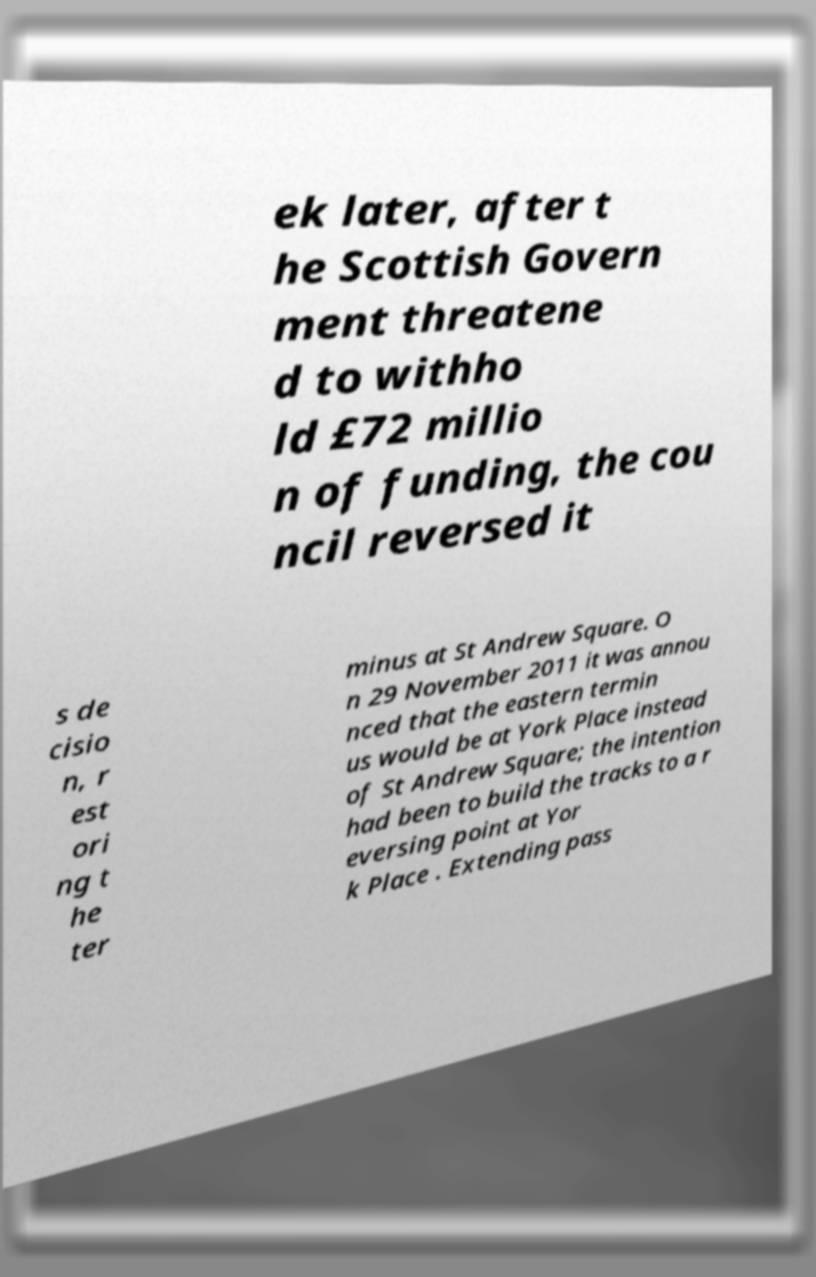For documentation purposes, I need the text within this image transcribed. Could you provide that? ek later, after t he Scottish Govern ment threatene d to withho ld £72 millio n of funding, the cou ncil reversed it s de cisio n, r est ori ng t he ter minus at St Andrew Square. O n 29 November 2011 it was annou nced that the eastern termin us would be at York Place instead of St Andrew Square; the intention had been to build the tracks to a r eversing point at Yor k Place . Extending pass 